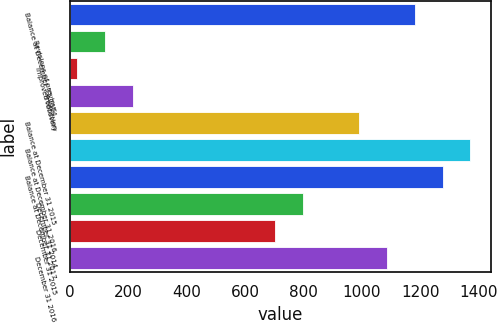<chart> <loc_0><loc_0><loc_500><loc_500><bar_chart><fcel>Balance at December 31 2014<fcel>Revisions of previous<fcel>Improved recovery<fcel>Production<fcel>Balance at December 31 2015<fcel>Balance at December 31 2016<fcel>Balance at December 31 2017<fcel>December 31 2014<fcel>December 31 2015<fcel>December 31 2016<nl><fcel>1181<fcel>118.8<fcel>23<fcel>214.6<fcel>989.4<fcel>1372.6<fcel>1276.8<fcel>797.8<fcel>702<fcel>1085.2<nl></chart> 